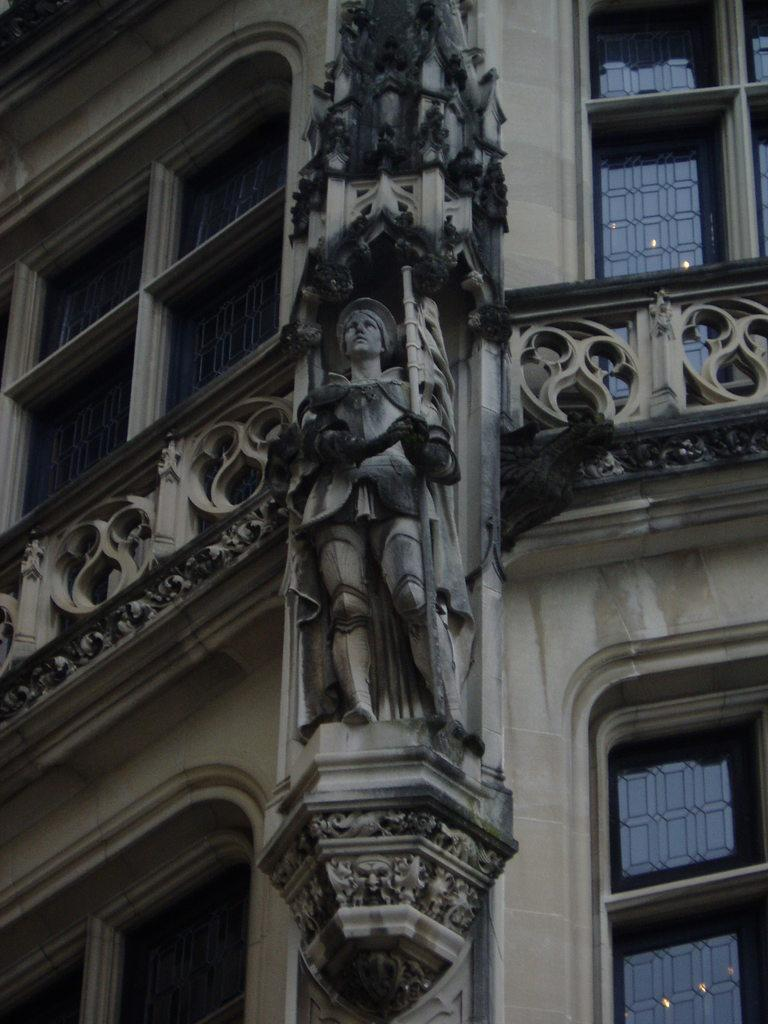What type of structure is visible in the image? There is a building in the image. What is located on the building? There is a statue on the building. What feature of the building allows light to enter the interior? There are windows on the building. What type of current can be seen flowing through the statue in the image? There is no current flowing through the statue in the image, as it is a static object. 